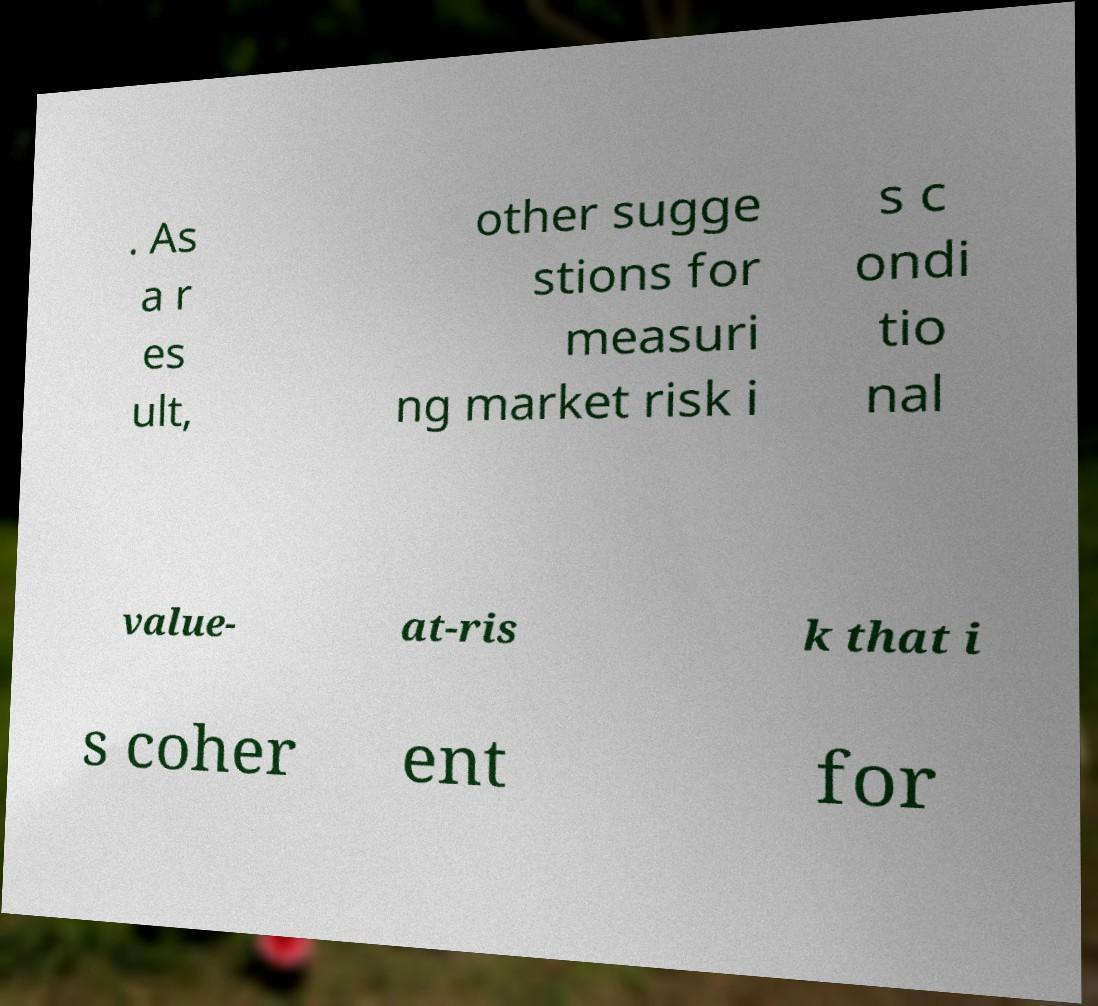Please identify and transcribe the text found in this image. . As a r es ult, other sugge stions for measuri ng market risk i s c ondi tio nal value- at-ris k that i s coher ent for 